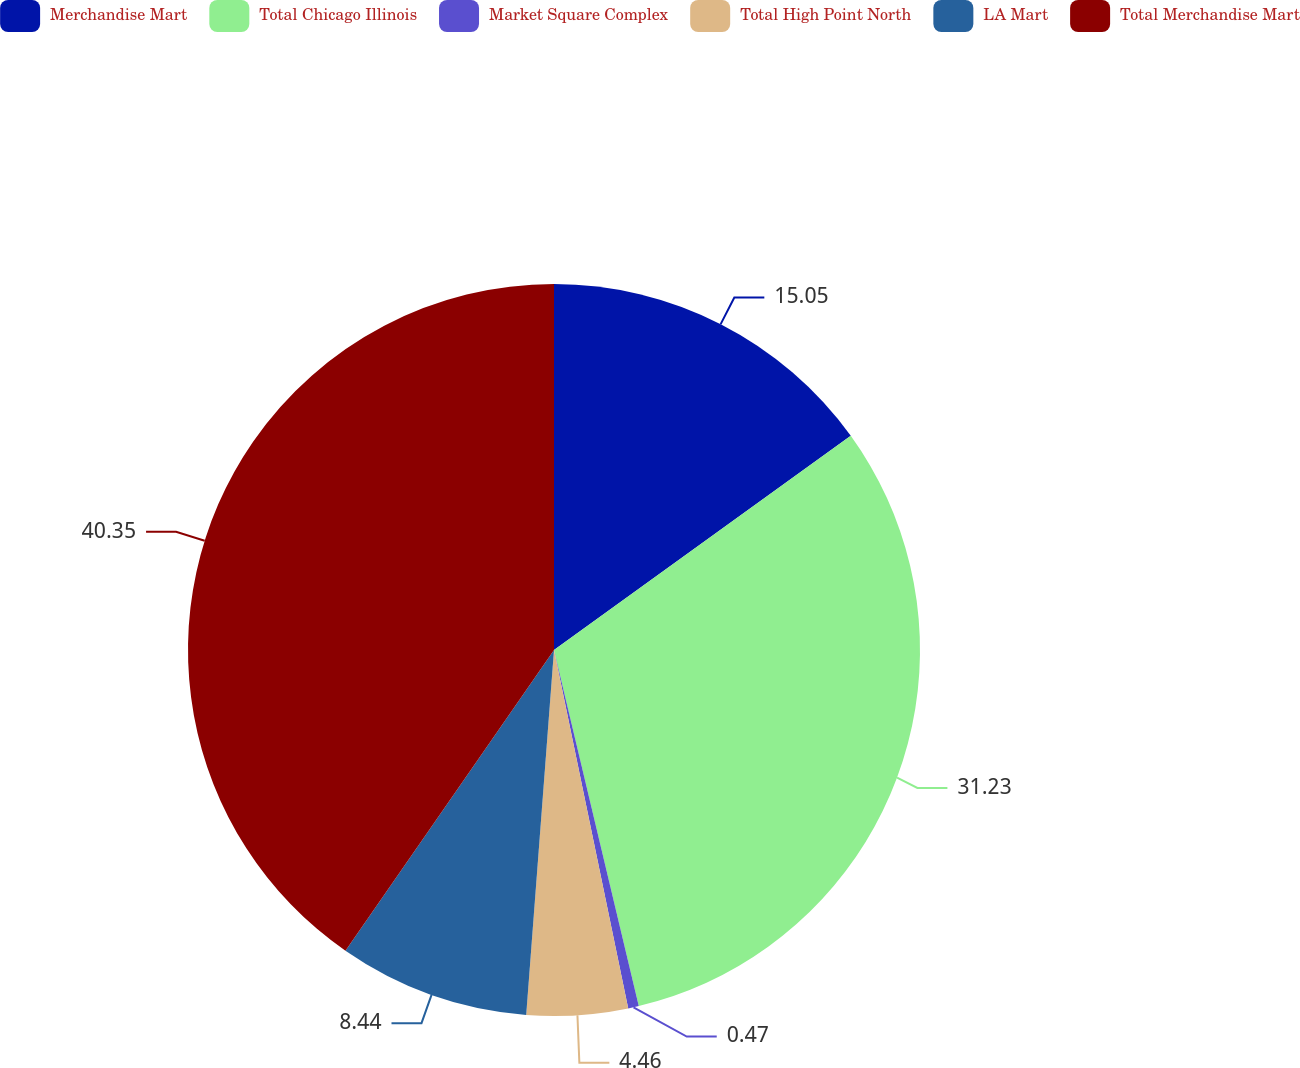Convert chart. <chart><loc_0><loc_0><loc_500><loc_500><pie_chart><fcel>Merchandise Mart<fcel>Total Chicago Illinois<fcel>Market Square Complex<fcel>Total High Point North<fcel>LA Mart<fcel>Total Merchandise Mart<nl><fcel>15.05%<fcel>31.23%<fcel>0.47%<fcel>4.46%<fcel>8.44%<fcel>40.35%<nl></chart> 